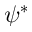Convert formula to latex. <formula><loc_0><loc_0><loc_500><loc_500>\psi ^ { * }</formula> 